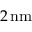<formula> <loc_0><loc_0><loc_500><loc_500>2 \, n m</formula> 